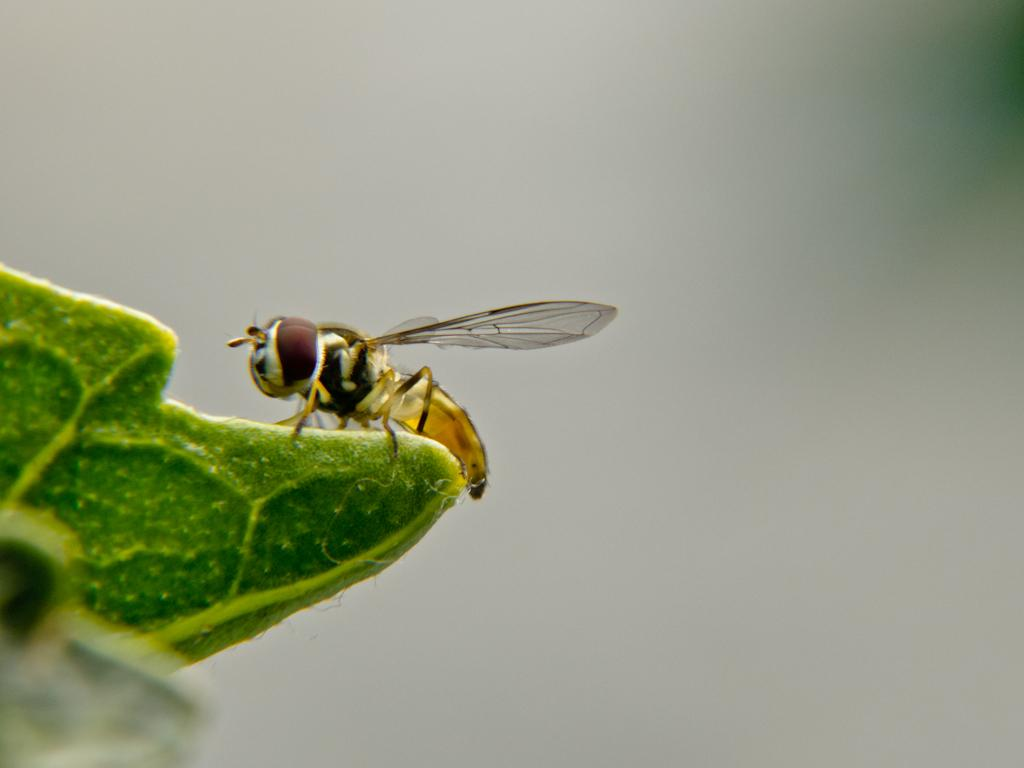What type of creature is in the image? There is an insect in the image. What is the insect resting on? The insect is on a green surface. What color is the background of the image? The background of the image is white. What type of flesh can be seen on the insect's throne in the image? There is no throne or flesh present in the image; it features an insect on a green surface with a white background. 